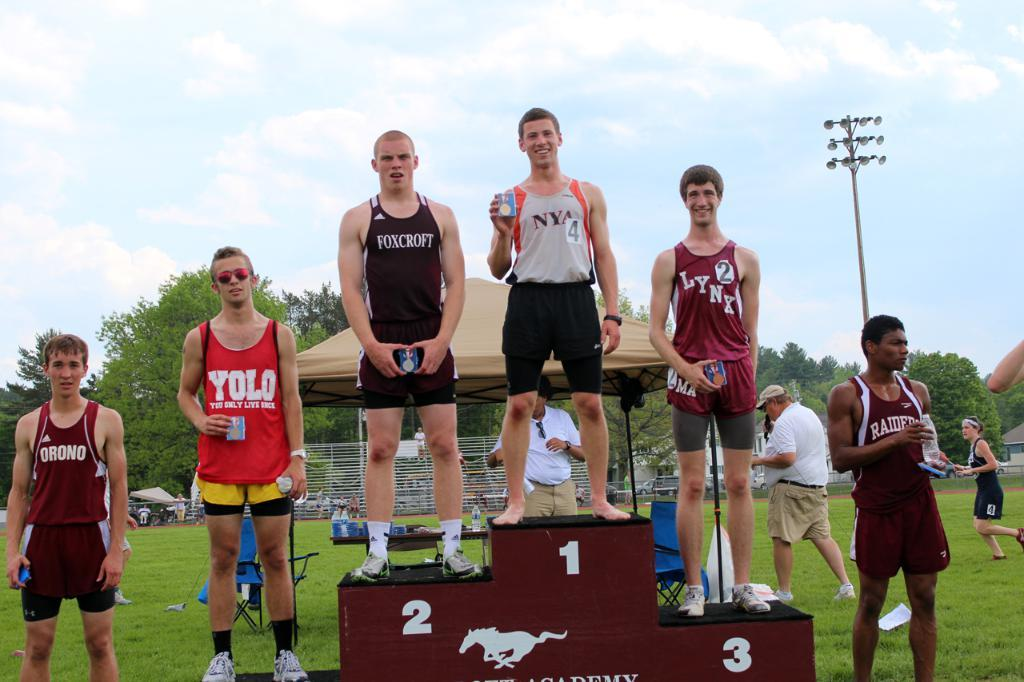<image>
Render a clear and concise summary of the photo. The athlete from NYA takes the top place at the podium during a track and field event. 